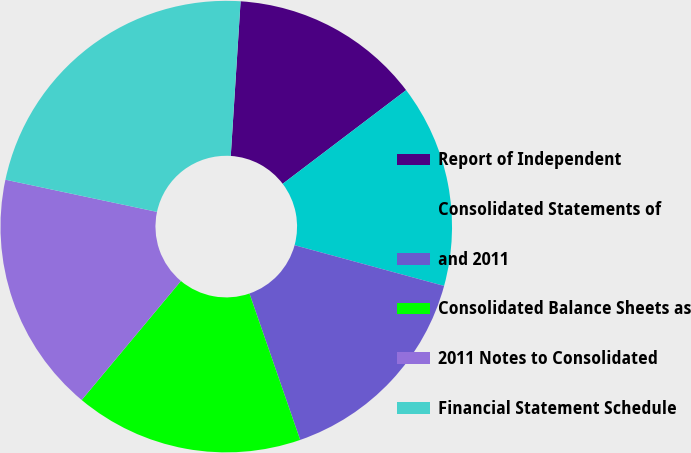<chart> <loc_0><loc_0><loc_500><loc_500><pie_chart><fcel>Report of Independent<fcel>Consolidated Statements of<fcel>and 2011<fcel>Consolidated Balance Sheets as<fcel>2011 Notes to Consolidated<fcel>Financial Statement Schedule<nl><fcel>13.66%<fcel>14.56%<fcel>15.46%<fcel>16.37%<fcel>17.27%<fcel>22.68%<nl></chart> 